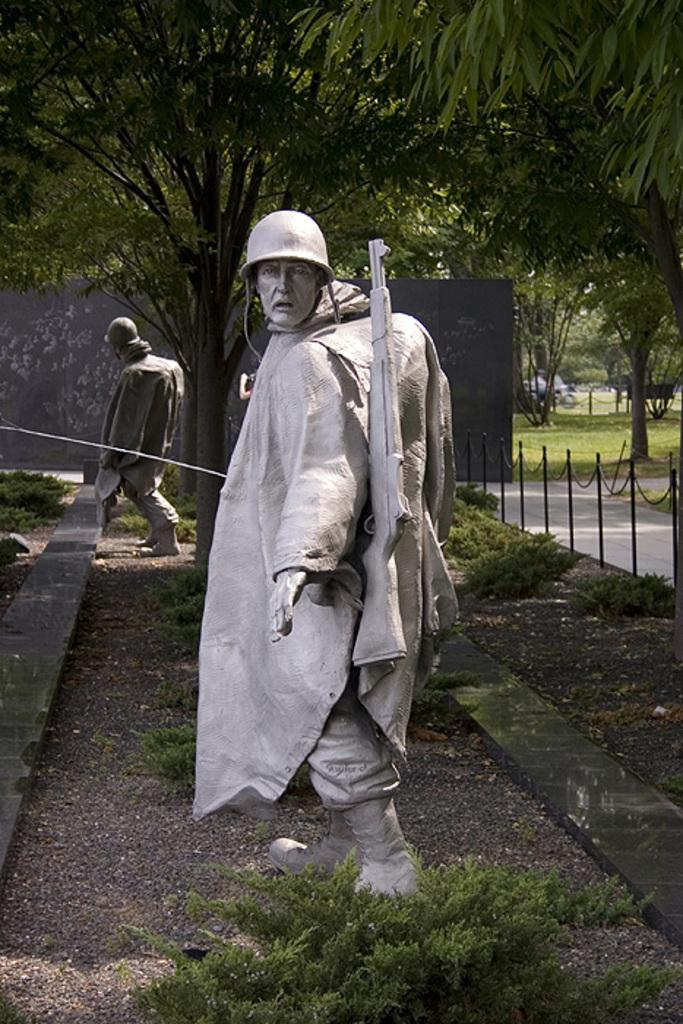What type of objects can be seen in the image? There are statues in the image. What can be seen beneath the statues? The ground is visible in the image. What type of vegetation is present in the image? There are plants, grass, and trees in the image. What architectural feature can be seen in the image? There is a railing and a wall in the image. What type of pathway is visible in the image? There is a road in the image. What type of joke can be heard coming from the statues in the image? There is no indication in the image that the statues are making any jokes or producing any sounds. 